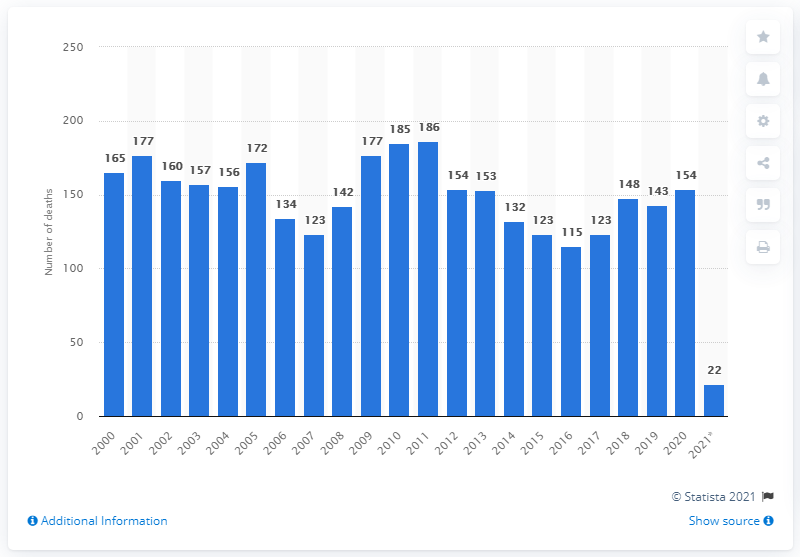Indicate a few pertinent items in this graphic. During the first three months of 2021, a total of 22 prisoners died. The highest number of deaths in jail between 2000 and 2020 was 186. 